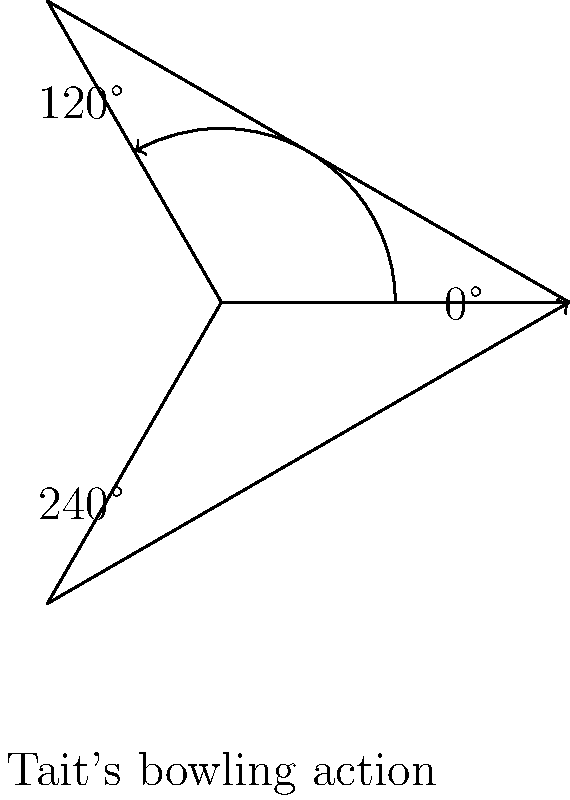In Shaun Tait's signature fast bowling action, his arm completes a full rotation. If his bowling arm starts at 0° and reaches the release point at 240°, what is the angle of rotation from the starting position to the release point? To find the angle of rotation in Shaun Tait's bowling action, we need to follow these steps:

1. Identify the starting position: 0°
2. Identify the release point: 240°
3. Calculate the angle of rotation:
   
   The angle of rotation is the difference between the release point and the starting position.
   
   $$\text{Angle of rotation} = \text{Release point} - \text{Starting position}$$
   $$\text{Angle of rotation} = 240° - 0°$$
   $$\text{Angle of rotation} = 240°$$

4. Verify the result:
   The calculated angle represents the counterclockwise rotation from the starting position (0°) to the release point (240°) in Tait's bowling action, which matches the description in the question.

Therefore, the angle of rotation in Shaun Tait's signature fast bowling action from the starting position to the release point is 240°.
Answer: 240° 